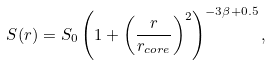Convert formula to latex. <formula><loc_0><loc_0><loc_500><loc_500>S ( r ) = S _ { 0 } \left ( 1 + \left ( \frac { r } { r _ { c o r e } } \right ) ^ { 2 } \right ) ^ { - 3 \beta + 0 . 5 } ,</formula> 